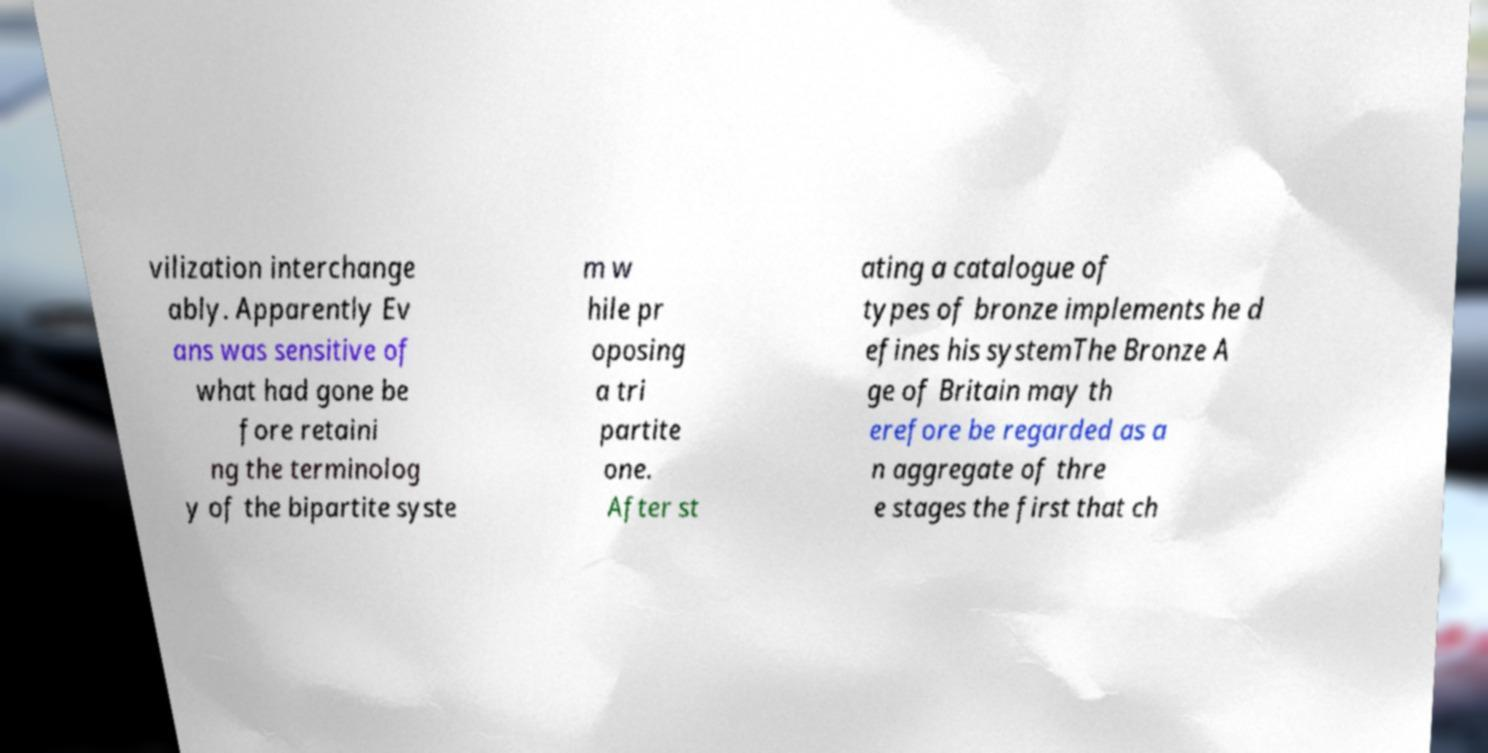Could you extract and type out the text from this image? vilization interchange ably. Apparently Ev ans was sensitive of what had gone be fore retaini ng the terminolog y of the bipartite syste m w hile pr oposing a tri partite one. After st ating a catalogue of types of bronze implements he d efines his systemThe Bronze A ge of Britain may th erefore be regarded as a n aggregate of thre e stages the first that ch 